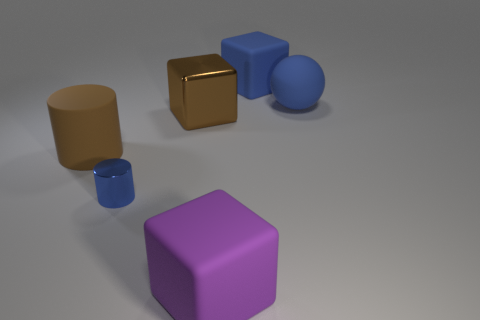What can you infer about the texture of the objects? From the visual cues, it appears that the objects have different textures. The golden cube seems to have a shiny, metallic surface, while the brown cylinder and the large purple cube likely have a matte, rubber-like texture. The blue objects have a smooth and possibly plastic finish. 